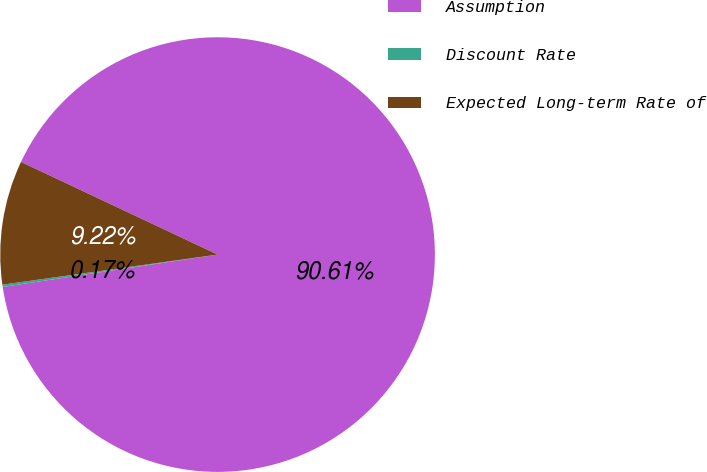<chart> <loc_0><loc_0><loc_500><loc_500><pie_chart><fcel>Assumption<fcel>Discount Rate<fcel>Expected Long-term Rate of<nl><fcel>90.61%<fcel>0.17%<fcel>9.22%<nl></chart> 